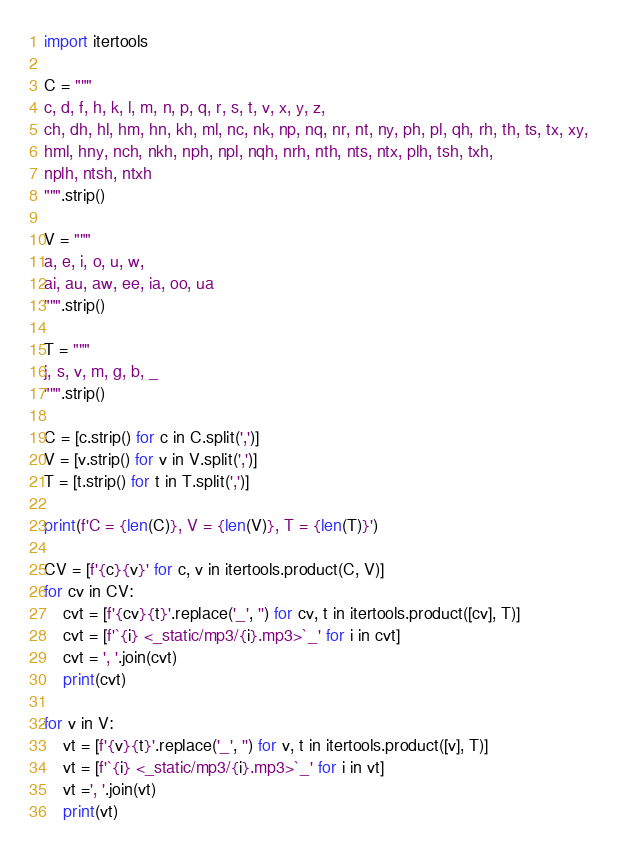<code> <loc_0><loc_0><loc_500><loc_500><_Python_>
import itertools

C = """
c, d, f, h, k, l, m, n, p, q, r, s, t, v, x, y, z,
ch, dh, hl, hm, hn, kh, ml, nc, nk, np, nq, nr, nt, ny, ph, pl, qh, rh, th, ts, tx, xy,
hml, hny, nch, nkh, nph, npl, nqh, nrh, nth, nts, ntx, plh, tsh, txh,
nplh, ntsh, ntxh
""".strip()

V = """
a, e, i, o, u, w,
ai, au, aw, ee, ia, oo, ua
""".strip()

T = """
j, s, v, m, g, b, _
""".strip()

C = [c.strip() for c in C.split(',')]
V = [v.strip() for v in V.split(',')]
T = [t.strip() for t in T.split(',')]

print(f'C = {len(C)}, V = {len(V)}, T = {len(T)}')

CV = [f'{c}{v}' for c, v in itertools.product(C, V)]
for cv in CV:
    cvt = [f'{cv}{t}'.replace('_', '') for cv, t in itertools.product([cv], T)]
    cvt = [f'`{i} <_static/mp3/{i}.mp3>`_' for i in cvt]
    cvt = ', '.join(cvt)
    print(cvt)

for v in V:
    vt = [f'{v}{t}'.replace('_', '') for v, t in itertools.product([v], T)]
    vt = [f'`{i} <_static/mp3/{i}.mp3>`_' for i in vt]
    vt =', '.join(vt)
    print(vt)</code> 